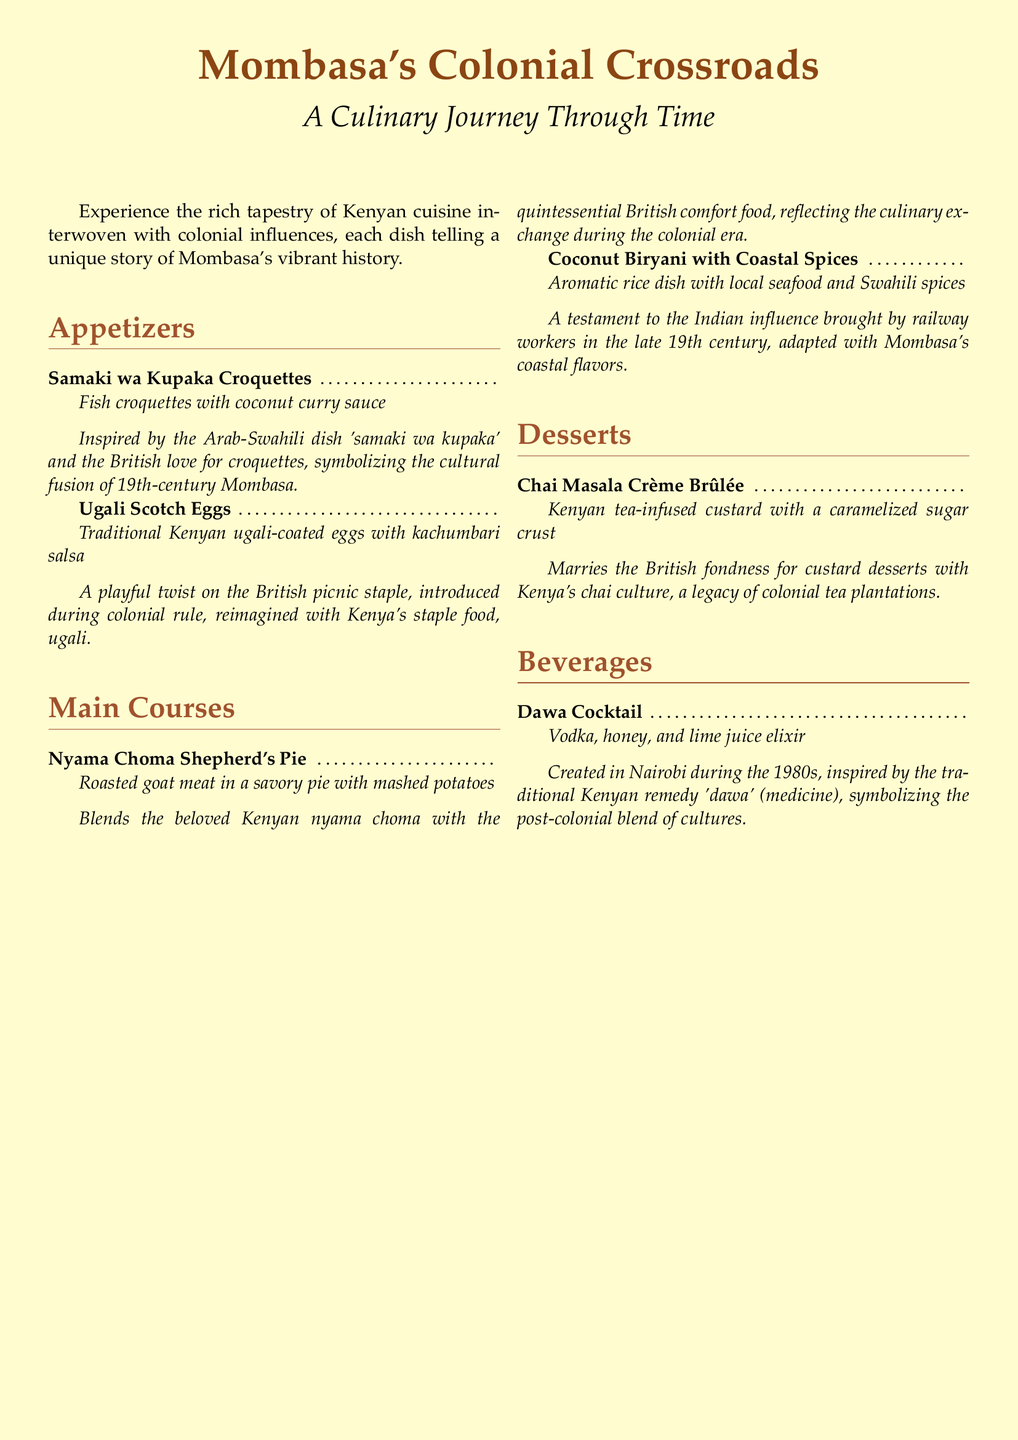What is the first appetizer listed? The first appetizer listed in the menu is "Samaki wa Kupaka Croquettes."
Answer: Samaki wa Kupaka Croquettes What dish is a playful twist on a British picnic staple? The dish that is a playful twist on a British picnic staple is the "Ugali Scotch Eggs."
Answer: Ugali Scotch Eggs What flavor is incorporated into the Chai Masala Crème Brûlée? The flavor incorporated into the Chai Masala Crème Brûlée is Kenyan tea.
Answer: Kenyan tea How many main courses are featured in the menu? There are two main courses featured in the menu, which are "Nyama Choma Shepherd's Pie" and "Coconut Biryani with Coastal Spices."
Answer: Two Which colonial influence is reflected in the Coconut Biryani with Coastal Spices? The Indian influence brought by railway workers is reflected in the Coconut Biryani with Coastal Spices.
Answer: Indian influence What is the primary spirit used in the Dawa Cocktail? The primary spirit used in the Dawa Cocktail is vodka.
Answer: Vodka What traditional Kenyan remedy does the Dawa Cocktail symbolize? The Dawa Cocktail symbolizes the traditional Kenyan remedy called 'dawa.'
Answer: 'Dawa' Which dish combines goat meat with mashed potatoes? The dish that combines goat meat with mashed potatoes is "Nyama Choma Shepherd's Pie."
Answer: Nyama Choma Shepherd's Pie What is the dessert type that blends British custard culture? The dessert that blends British custard culture is the Crème Brûlée.
Answer: Crème Brûlée 